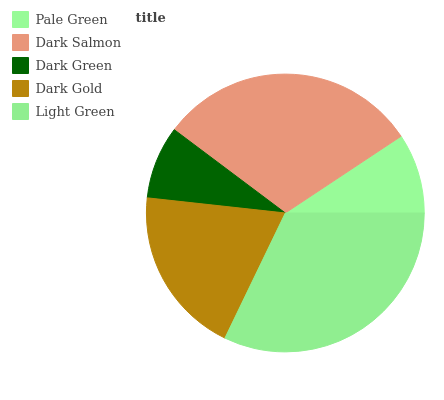Is Dark Green the minimum?
Answer yes or no. Yes. Is Light Green the maximum?
Answer yes or no. Yes. Is Dark Salmon the minimum?
Answer yes or no. No. Is Dark Salmon the maximum?
Answer yes or no. No. Is Dark Salmon greater than Pale Green?
Answer yes or no. Yes. Is Pale Green less than Dark Salmon?
Answer yes or no. Yes. Is Pale Green greater than Dark Salmon?
Answer yes or no. No. Is Dark Salmon less than Pale Green?
Answer yes or no. No. Is Dark Gold the high median?
Answer yes or no. Yes. Is Dark Gold the low median?
Answer yes or no. Yes. Is Pale Green the high median?
Answer yes or no. No. Is Dark Green the low median?
Answer yes or no. No. 